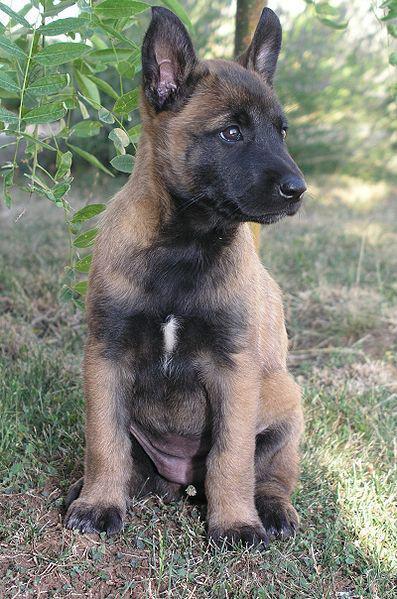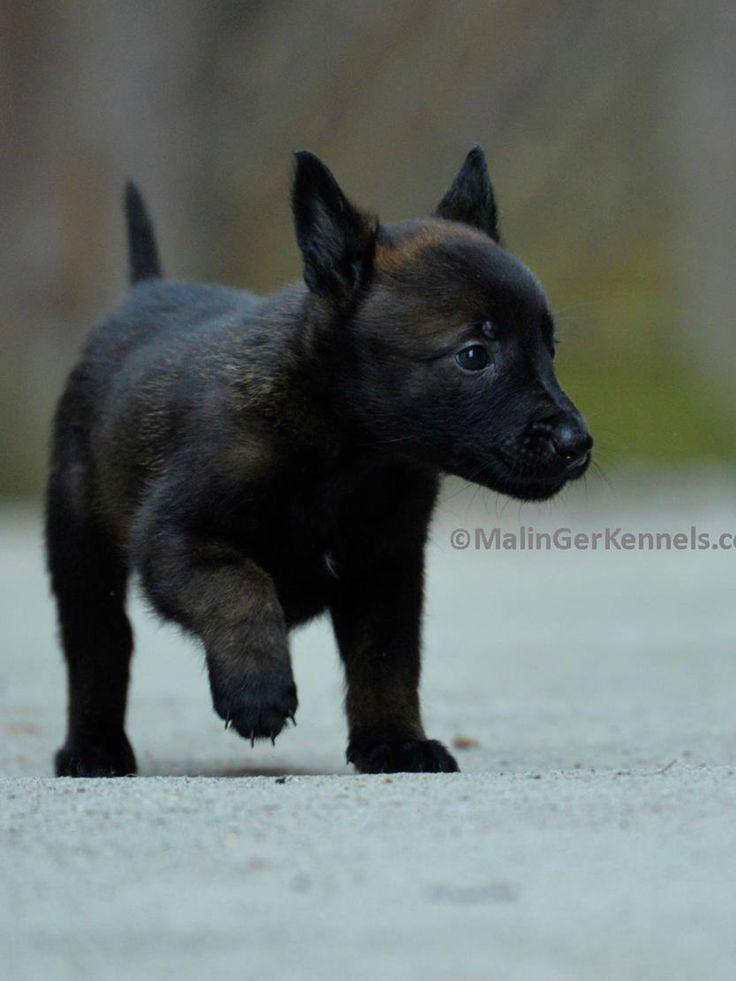The first image is the image on the left, the second image is the image on the right. Evaluate the accuracy of this statement regarding the images: "A little dog in one image, with ears and tail standing up, has one front paw up in a walking stance.". Is it true? Answer yes or no. Yes. The first image is the image on the left, the second image is the image on the right. For the images displayed, is the sentence "A brown puppy has a visible leash." factually correct? Answer yes or no. No. 